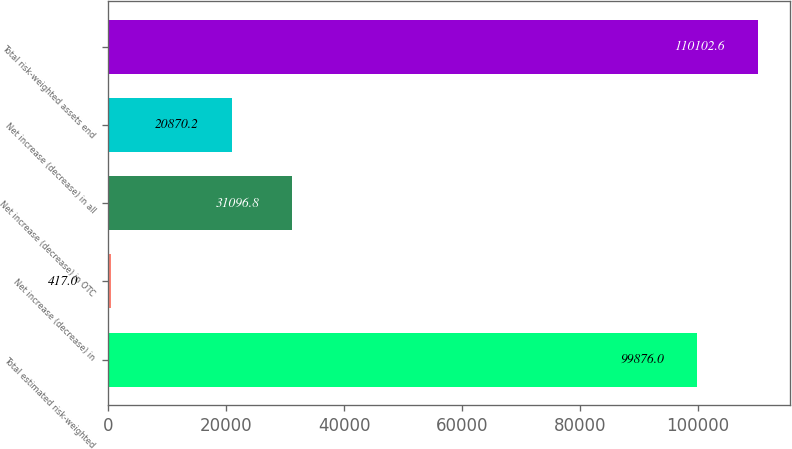<chart> <loc_0><loc_0><loc_500><loc_500><bar_chart><fcel>Total estimated risk-weighted<fcel>Net increase (decrease) in<fcel>Net increase (decrease) in OTC<fcel>Net increase (decrease) in all<fcel>Total risk-weighted assets end<nl><fcel>99876<fcel>417<fcel>31096.8<fcel>20870.2<fcel>110103<nl></chart> 